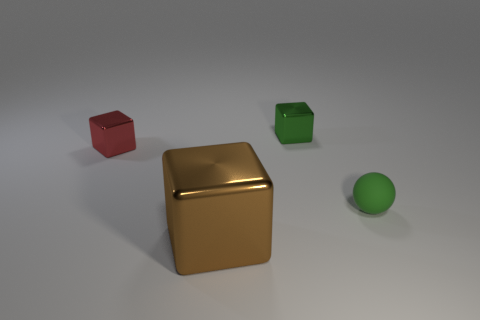Is there any other thing that is made of the same material as the green sphere?
Give a very brief answer. No. How many objects are tiny red rubber cylinders or green objects that are left of the rubber thing?
Keep it short and to the point. 1. Are there any other small shiny things of the same shape as the tiny red metal thing?
Offer a terse response. Yes. There is a object right of the small metallic object that is right of the large thing; what size is it?
Provide a succinct answer. Small. Do the ball and the big metallic block have the same color?
Offer a very short reply. No. How many metallic things are either large brown cubes or green cubes?
Your answer should be compact. 2. What number of brown shiny cubes are there?
Ensure brevity in your answer.  1. Are the tiny cube in front of the green cube and the small cube right of the brown metallic object made of the same material?
Make the answer very short. Yes. The other tiny shiny object that is the same shape as the green metallic object is what color?
Your answer should be compact. Red. There is a small thing that is on the left side of the tiny green object to the left of the tiny ball; what is it made of?
Keep it short and to the point. Metal. 